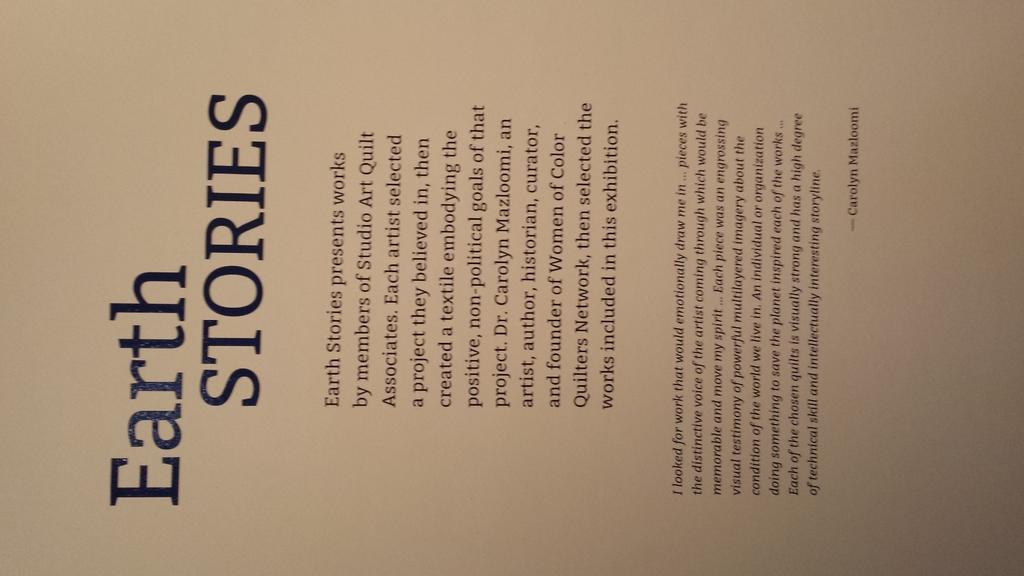<image>
Describe the image concisely. A sideways photo of a book cover that reads Earth STORIES. 